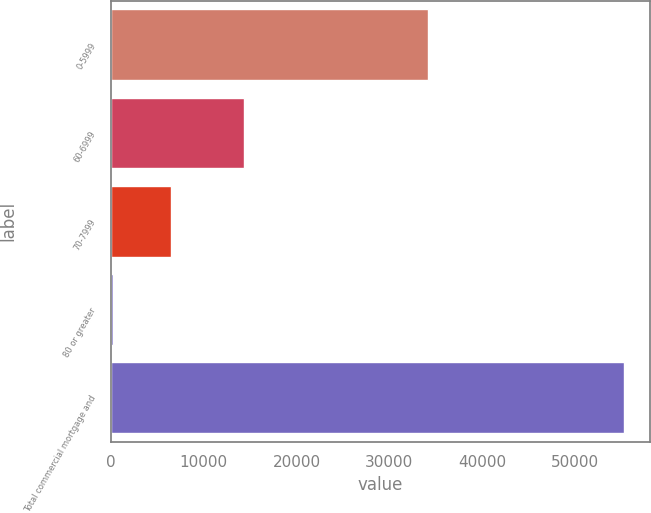Convert chart. <chart><loc_0><loc_0><loc_500><loc_500><bar_chart><fcel>0-5999<fcel>60-6999<fcel>70-7999<fcel>80 or greater<fcel>Total commercial mortgage and<nl><fcel>34135<fcel>14349<fcel>6537<fcel>266<fcel>55287<nl></chart> 